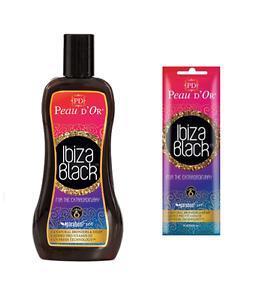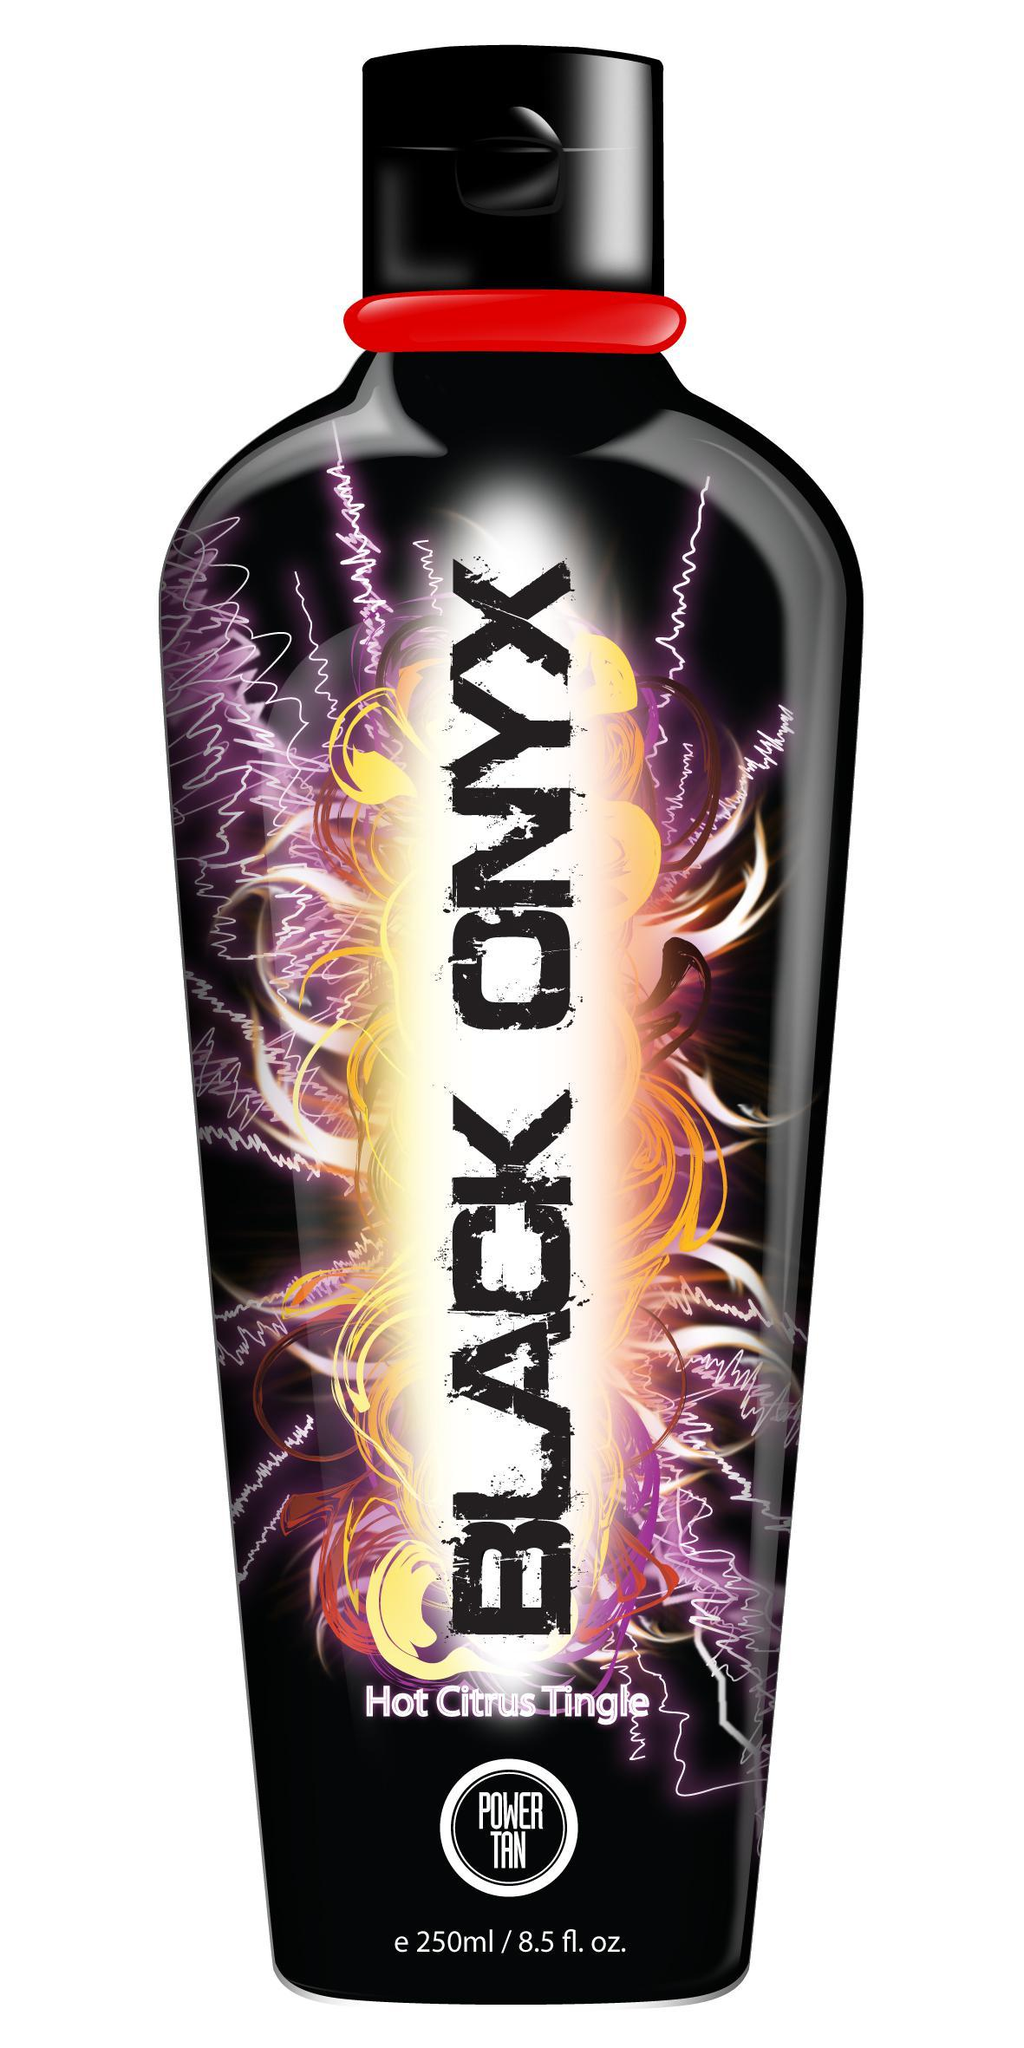The first image is the image on the left, the second image is the image on the right. Assess this claim about the two images: "The image to the right features nothing more than one single bottle.". Correct or not? Answer yes or no. Yes. The first image is the image on the left, the second image is the image on the right. Given the left and right images, does the statement "there is no more then three items" hold true? Answer yes or no. Yes. 